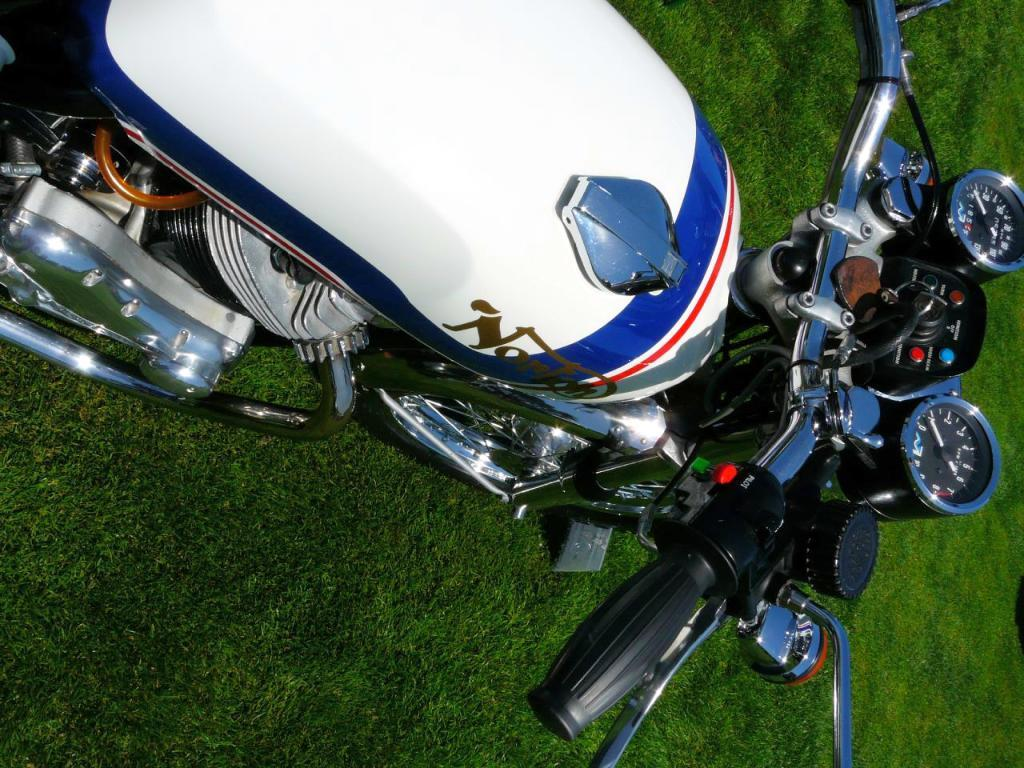What type of vehicle is partially visible in the image? The front part of a bike is visible in the image. What part of the bike is used for steering? The handle of the bike is present. How many meters are shown on the bike? There are two meters on the bike. What is used to store fuel in the bike? The petrol tank of the bike is shown. What type of vegetation is present in the foreground of the image? Some grass is present in the foreground of the image. Where is the crown placed on the bike in the image? There is no crown present on the bike or in the image. 